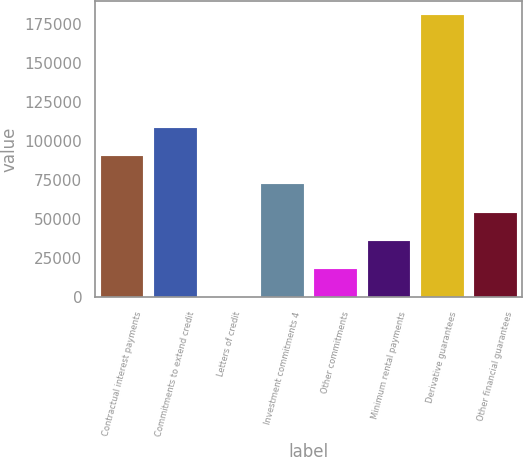Convert chart. <chart><loc_0><loc_0><loc_500><loc_500><bar_chart><fcel>Contractual interest payments<fcel>Commitments to extend credit<fcel>Letters of credit<fcel>Investment commitments 4<fcel>Other commitments<fcel>Minimum rental payments<fcel>Derivative guarantees<fcel>Other financial guarantees<nl><fcel>90282<fcel>108334<fcel>21<fcel>72229.8<fcel>18073.2<fcel>36125.4<fcel>180543<fcel>54177.6<nl></chart> 